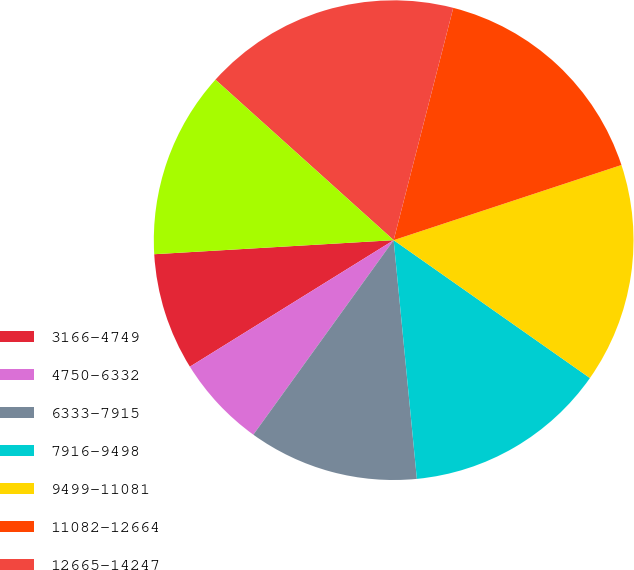Convert chart. <chart><loc_0><loc_0><loc_500><loc_500><pie_chart><fcel>3166-4749<fcel>4750-6332<fcel>6333-7915<fcel>7916-9498<fcel>9499-11081<fcel>11082-12664<fcel>12665-14247<fcel>3166-15830<nl><fcel>7.91%<fcel>6.21%<fcel>11.49%<fcel>13.71%<fcel>14.82%<fcel>15.93%<fcel>17.33%<fcel>12.6%<nl></chart> 